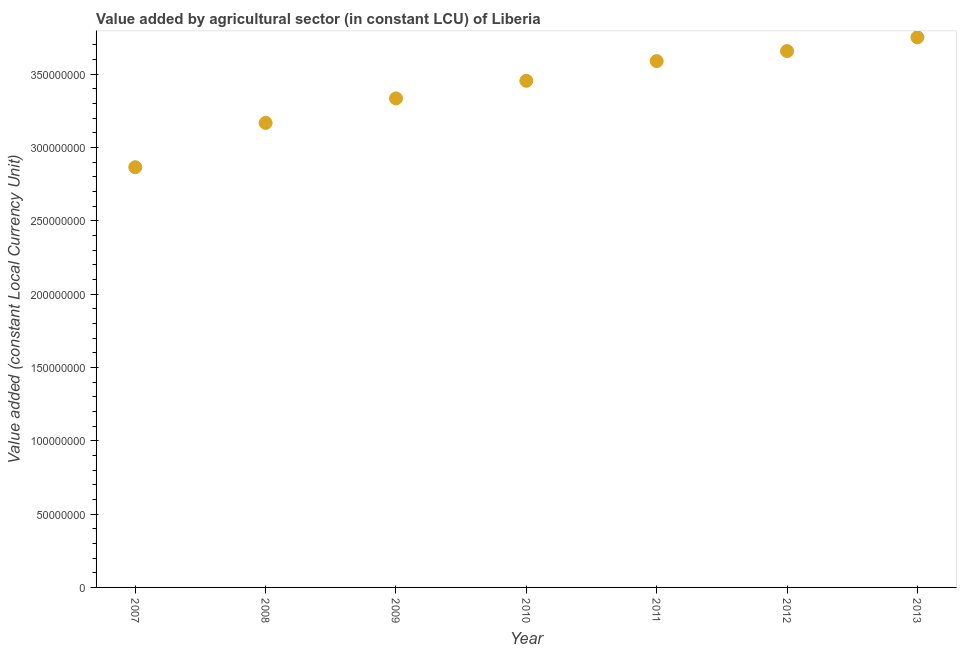What is the value added by agriculture sector in 2011?
Provide a succinct answer. 3.59e+08. Across all years, what is the maximum value added by agriculture sector?
Make the answer very short. 3.75e+08. Across all years, what is the minimum value added by agriculture sector?
Ensure brevity in your answer.  2.87e+08. In which year was the value added by agriculture sector minimum?
Provide a succinct answer. 2007. What is the sum of the value added by agriculture sector?
Offer a very short reply. 2.38e+09. What is the difference between the value added by agriculture sector in 2007 and 2012?
Ensure brevity in your answer.  -7.92e+07. What is the average value added by agriculture sector per year?
Your answer should be very brief. 3.40e+08. What is the median value added by agriculture sector?
Give a very brief answer. 3.45e+08. What is the ratio of the value added by agriculture sector in 2010 to that in 2013?
Keep it short and to the point. 0.92. Is the value added by agriculture sector in 2008 less than that in 2010?
Provide a short and direct response. Yes. What is the difference between the highest and the second highest value added by agriculture sector?
Your response must be concise. 9.39e+06. Is the sum of the value added by agriculture sector in 2010 and 2013 greater than the maximum value added by agriculture sector across all years?
Provide a short and direct response. Yes. What is the difference between the highest and the lowest value added by agriculture sector?
Provide a succinct answer. 8.86e+07. How many years are there in the graph?
Offer a terse response. 7. Does the graph contain any zero values?
Offer a very short reply. No. Does the graph contain grids?
Your answer should be very brief. No. What is the title of the graph?
Your answer should be compact. Value added by agricultural sector (in constant LCU) of Liberia. What is the label or title of the X-axis?
Your answer should be compact. Year. What is the label or title of the Y-axis?
Give a very brief answer. Value added (constant Local Currency Unit). What is the Value added (constant Local Currency Unit) in 2007?
Provide a succinct answer. 2.87e+08. What is the Value added (constant Local Currency Unit) in 2008?
Make the answer very short. 3.17e+08. What is the Value added (constant Local Currency Unit) in 2009?
Make the answer very short. 3.33e+08. What is the Value added (constant Local Currency Unit) in 2010?
Your response must be concise. 3.45e+08. What is the Value added (constant Local Currency Unit) in 2011?
Provide a short and direct response. 3.59e+08. What is the Value added (constant Local Currency Unit) in 2012?
Keep it short and to the point. 3.66e+08. What is the Value added (constant Local Currency Unit) in 2013?
Ensure brevity in your answer.  3.75e+08. What is the difference between the Value added (constant Local Currency Unit) in 2007 and 2008?
Provide a succinct answer. -3.02e+07. What is the difference between the Value added (constant Local Currency Unit) in 2007 and 2009?
Keep it short and to the point. -4.69e+07. What is the difference between the Value added (constant Local Currency Unit) in 2007 and 2010?
Ensure brevity in your answer.  -5.89e+07. What is the difference between the Value added (constant Local Currency Unit) in 2007 and 2011?
Provide a short and direct response. -7.24e+07. What is the difference between the Value added (constant Local Currency Unit) in 2007 and 2012?
Keep it short and to the point. -7.92e+07. What is the difference between the Value added (constant Local Currency Unit) in 2007 and 2013?
Your answer should be compact. -8.86e+07. What is the difference between the Value added (constant Local Currency Unit) in 2008 and 2009?
Your response must be concise. -1.67e+07. What is the difference between the Value added (constant Local Currency Unit) in 2008 and 2010?
Provide a succinct answer. -2.87e+07. What is the difference between the Value added (constant Local Currency Unit) in 2008 and 2011?
Ensure brevity in your answer.  -4.21e+07. What is the difference between the Value added (constant Local Currency Unit) in 2008 and 2012?
Offer a very short reply. -4.90e+07. What is the difference between the Value added (constant Local Currency Unit) in 2008 and 2013?
Your answer should be compact. -5.84e+07. What is the difference between the Value added (constant Local Currency Unit) in 2009 and 2010?
Provide a short and direct response. -1.20e+07. What is the difference between the Value added (constant Local Currency Unit) in 2009 and 2011?
Ensure brevity in your answer.  -2.54e+07. What is the difference between the Value added (constant Local Currency Unit) in 2009 and 2012?
Provide a succinct answer. -3.23e+07. What is the difference between the Value added (constant Local Currency Unit) in 2009 and 2013?
Your response must be concise. -4.17e+07. What is the difference between the Value added (constant Local Currency Unit) in 2010 and 2011?
Make the answer very short. -1.34e+07. What is the difference between the Value added (constant Local Currency Unit) in 2010 and 2012?
Offer a terse response. -2.03e+07. What is the difference between the Value added (constant Local Currency Unit) in 2010 and 2013?
Keep it short and to the point. -2.97e+07. What is the difference between the Value added (constant Local Currency Unit) in 2011 and 2012?
Your answer should be compact. -6.83e+06. What is the difference between the Value added (constant Local Currency Unit) in 2011 and 2013?
Make the answer very short. -1.62e+07. What is the difference between the Value added (constant Local Currency Unit) in 2012 and 2013?
Provide a short and direct response. -9.39e+06. What is the ratio of the Value added (constant Local Currency Unit) in 2007 to that in 2008?
Your answer should be very brief. 0.91. What is the ratio of the Value added (constant Local Currency Unit) in 2007 to that in 2009?
Give a very brief answer. 0.86. What is the ratio of the Value added (constant Local Currency Unit) in 2007 to that in 2010?
Give a very brief answer. 0.83. What is the ratio of the Value added (constant Local Currency Unit) in 2007 to that in 2011?
Your response must be concise. 0.8. What is the ratio of the Value added (constant Local Currency Unit) in 2007 to that in 2012?
Offer a terse response. 0.78. What is the ratio of the Value added (constant Local Currency Unit) in 2007 to that in 2013?
Provide a short and direct response. 0.76. What is the ratio of the Value added (constant Local Currency Unit) in 2008 to that in 2010?
Provide a succinct answer. 0.92. What is the ratio of the Value added (constant Local Currency Unit) in 2008 to that in 2011?
Keep it short and to the point. 0.88. What is the ratio of the Value added (constant Local Currency Unit) in 2008 to that in 2012?
Offer a terse response. 0.87. What is the ratio of the Value added (constant Local Currency Unit) in 2008 to that in 2013?
Your answer should be compact. 0.84. What is the ratio of the Value added (constant Local Currency Unit) in 2009 to that in 2011?
Your response must be concise. 0.93. What is the ratio of the Value added (constant Local Currency Unit) in 2009 to that in 2012?
Keep it short and to the point. 0.91. What is the ratio of the Value added (constant Local Currency Unit) in 2009 to that in 2013?
Your answer should be compact. 0.89. What is the ratio of the Value added (constant Local Currency Unit) in 2010 to that in 2011?
Offer a very short reply. 0.96. What is the ratio of the Value added (constant Local Currency Unit) in 2010 to that in 2012?
Provide a short and direct response. 0.94. What is the ratio of the Value added (constant Local Currency Unit) in 2010 to that in 2013?
Ensure brevity in your answer.  0.92. What is the ratio of the Value added (constant Local Currency Unit) in 2011 to that in 2012?
Make the answer very short. 0.98. 